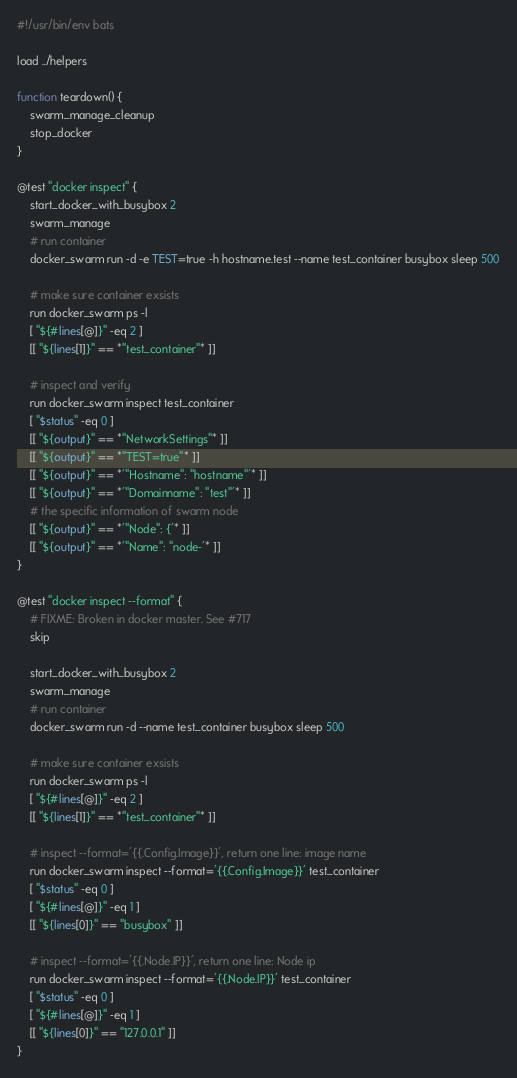Convert code to text. <code><loc_0><loc_0><loc_500><loc_500><_Bash_>#!/usr/bin/env bats

load ../helpers

function teardown() {
	swarm_manage_cleanup
	stop_docker
}

@test "docker inspect" {
	start_docker_with_busybox 2
	swarm_manage
	# run container
	docker_swarm run -d -e TEST=true -h hostname.test --name test_container busybox sleep 500

	# make sure container exsists
	run docker_swarm ps -l
	[ "${#lines[@]}" -eq 2 ]
	[[ "${lines[1]}" == *"test_container"* ]]

	# inspect and verify 
	run docker_swarm inspect test_container
	[ "$status" -eq 0 ]
	[[ "${output}" == *"NetworkSettings"* ]]
	[[ "${output}" == *"TEST=true"* ]]
	[[ "${output}" == *'"Hostname": "hostname"'* ]]
	[[ "${output}" == *'"Domainname": "test"'* ]]
	# the specific information of swarm node
	[[ "${output}" == *'"Node": {'* ]]
	[[ "${output}" == *'"Name": "node-'* ]]
}

@test "docker inspect --format" {
	# FIXME: Broken in docker master. See #717
	skip

	start_docker_with_busybox 2
	swarm_manage
	# run container
	docker_swarm run -d --name test_container busybox sleep 500

	# make sure container exsists
	run docker_swarm ps -l
	[ "${#lines[@]}" -eq 2 ]
	[[ "${lines[1]}" == *"test_container"* ]]

	# inspect --format='{{.Config.Image}}', return one line: image name
	run docker_swarm inspect --format='{{.Config.Image}}' test_container
	[ "$status" -eq 0 ]
	[ "${#lines[@]}" -eq 1 ]
	[[ "${lines[0]}" == "busybox" ]]

	# inspect --format='{{.Node.IP}}', return one line: Node ip
	run docker_swarm inspect --format='{{.Node.IP}}' test_container
	[ "$status" -eq 0 ]
	[ "${#lines[@]}" -eq 1 ]
	[[ "${lines[0]}" == "127.0.0.1" ]]
}
</code> 